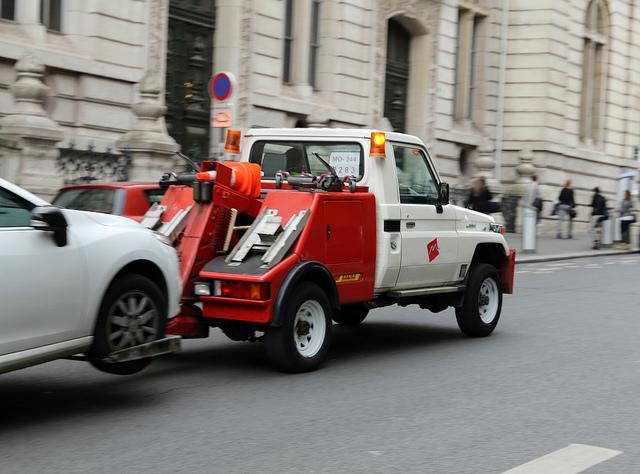What type of truck is being pictured in this image?

Choices:
A) sixteen wheeler
B) monster truck
C) chevy truck
D) tow truck tow truck 